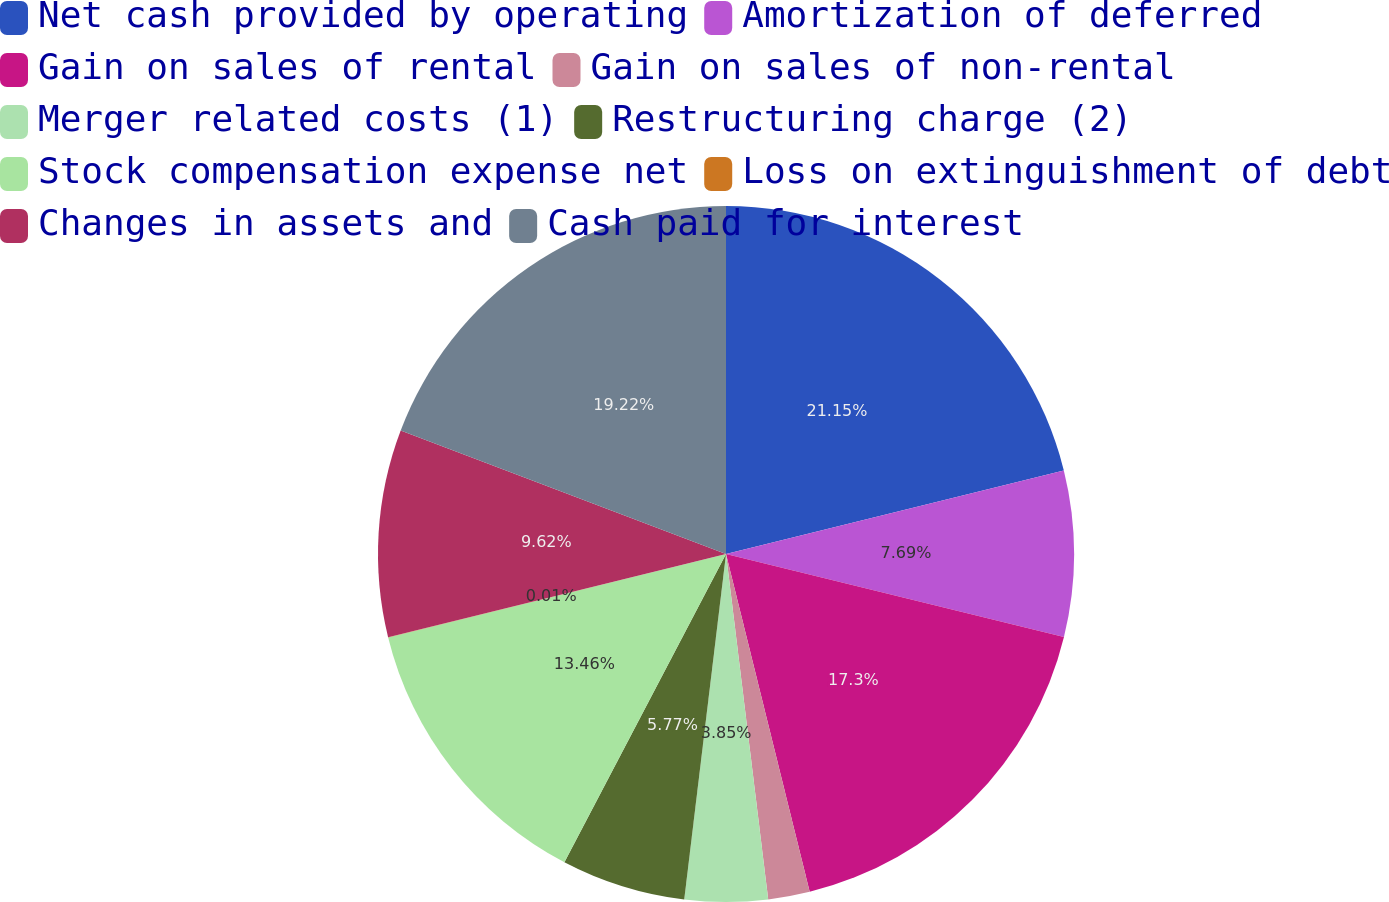<chart> <loc_0><loc_0><loc_500><loc_500><pie_chart><fcel>Net cash provided by operating<fcel>Amortization of deferred<fcel>Gain on sales of rental<fcel>Gain on sales of non-rental<fcel>Merger related costs (1)<fcel>Restructuring charge (2)<fcel>Stock compensation expense net<fcel>Loss on extinguishment of debt<fcel>Changes in assets and<fcel>Cash paid for interest<nl><fcel>21.14%<fcel>7.69%<fcel>17.3%<fcel>1.93%<fcel>3.85%<fcel>5.77%<fcel>13.46%<fcel>0.01%<fcel>9.62%<fcel>19.22%<nl></chart> 